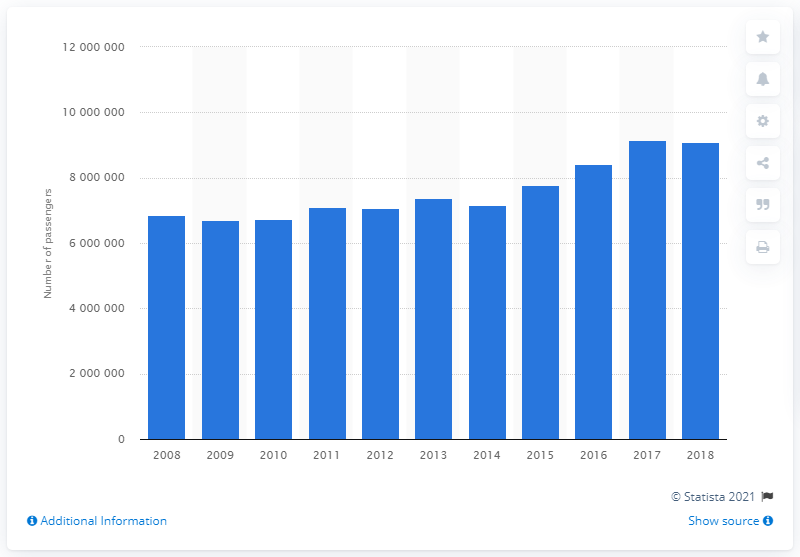Outline some significant characteristics in this image. In 2018, Flybe uplifted a total of 9,107,139 passengers. 